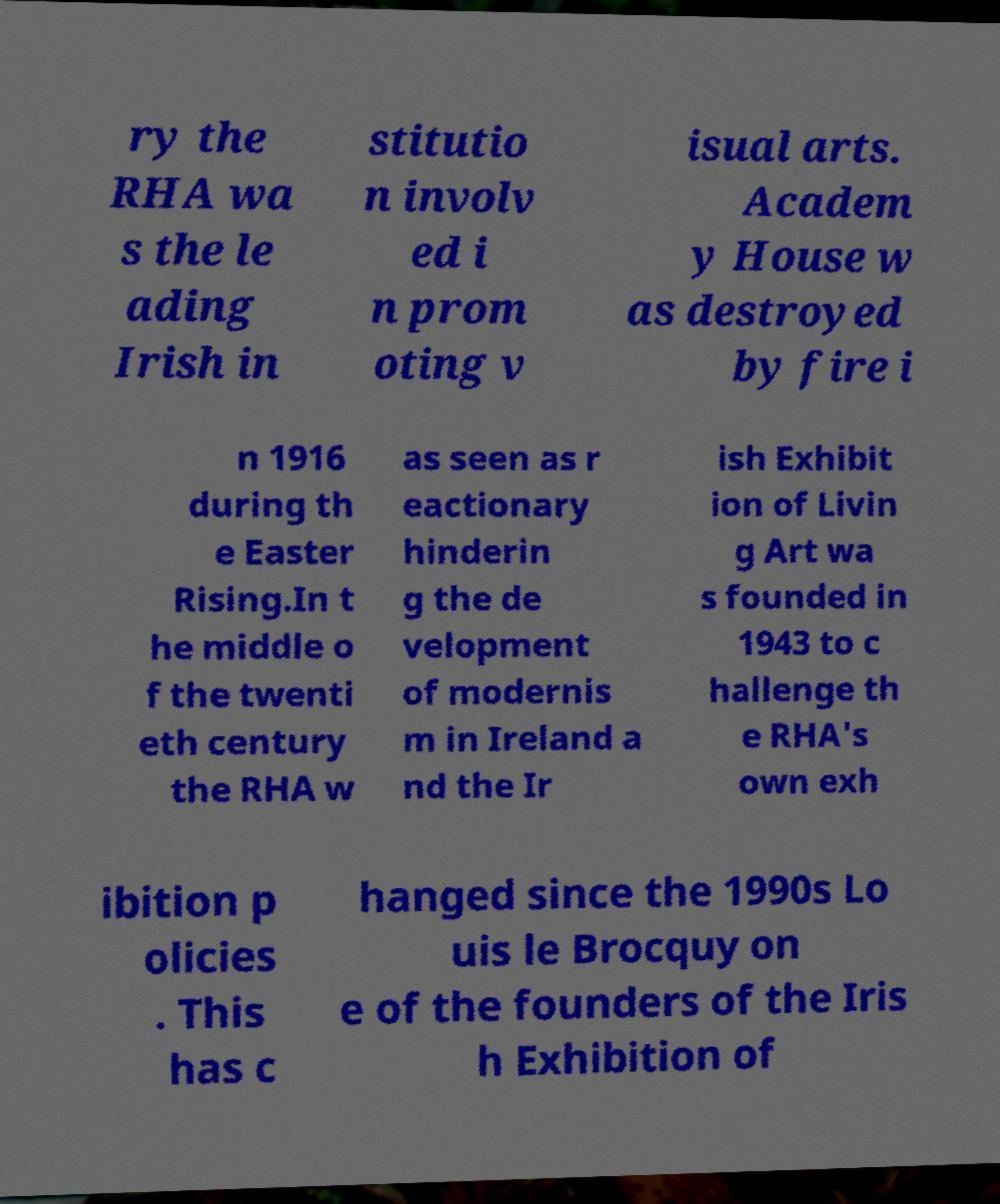Please identify and transcribe the text found in this image. ry the RHA wa s the le ading Irish in stitutio n involv ed i n prom oting v isual arts. Academ y House w as destroyed by fire i n 1916 during th e Easter Rising.In t he middle o f the twenti eth century the RHA w as seen as r eactionary hinderin g the de velopment of modernis m in Ireland a nd the Ir ish Exhibit ion of Livin g Art wa s founded in 1943 to c hallenge th e RHA's own exh ibition p olicies . This has c hanged since the 1990s Lo uis le Brocquy on e of the founders of the Iris h Exhibition of 